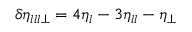Convert formula to latex. <formula><loc_0><loc_0><loc_500><loc_500>\delta \eta _ { l l l \perp } = 4 \eta _ { l } - 3 \eta _ { l l } - \eta _ { \perp }</formula> 